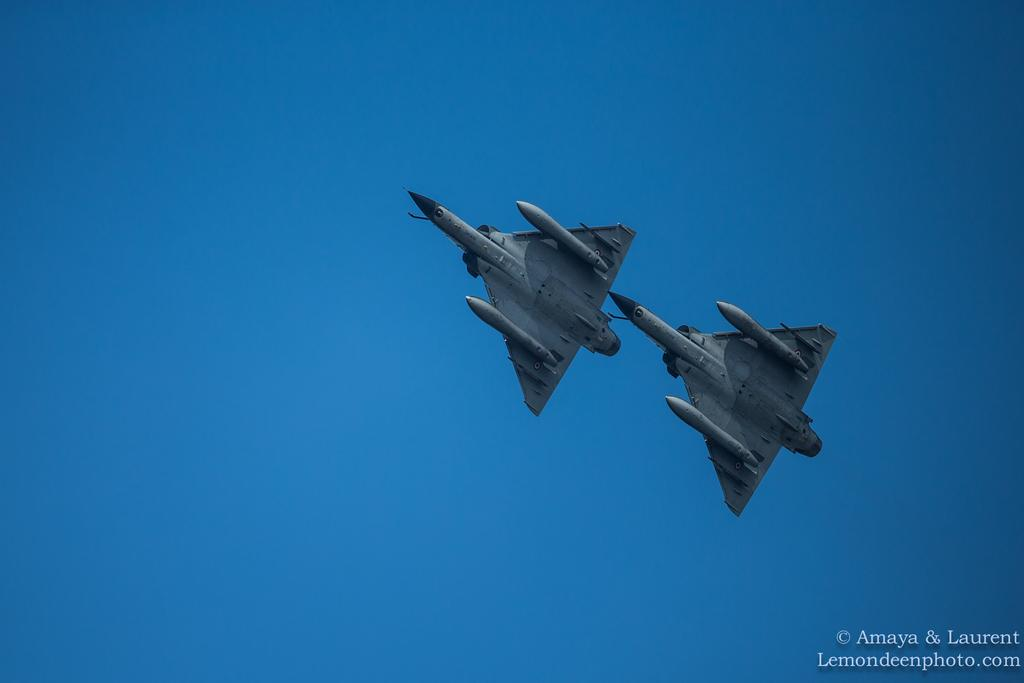Provide a one-sentence caption for the provided image. The picture shown here is from the website Lemondeepphoto.com. 